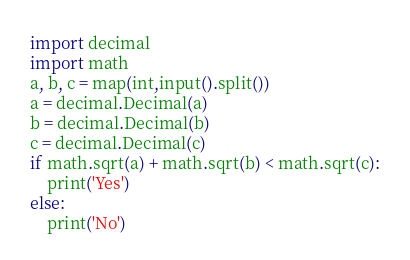Convert code to text. <code><loc_0><loc_0><loc_500><loc_500><_Python_>import decimal
import math
a, b, c = map(int,input().split())
a = decimal.Decimal(a)
b = decimal.Decimal(b)
c = decimal.Decimal(c)
if math.sqrt(a) + math.sqrt(b) < math.sqrt(c):
    print('Yes')
else:
    print('No')</code> 